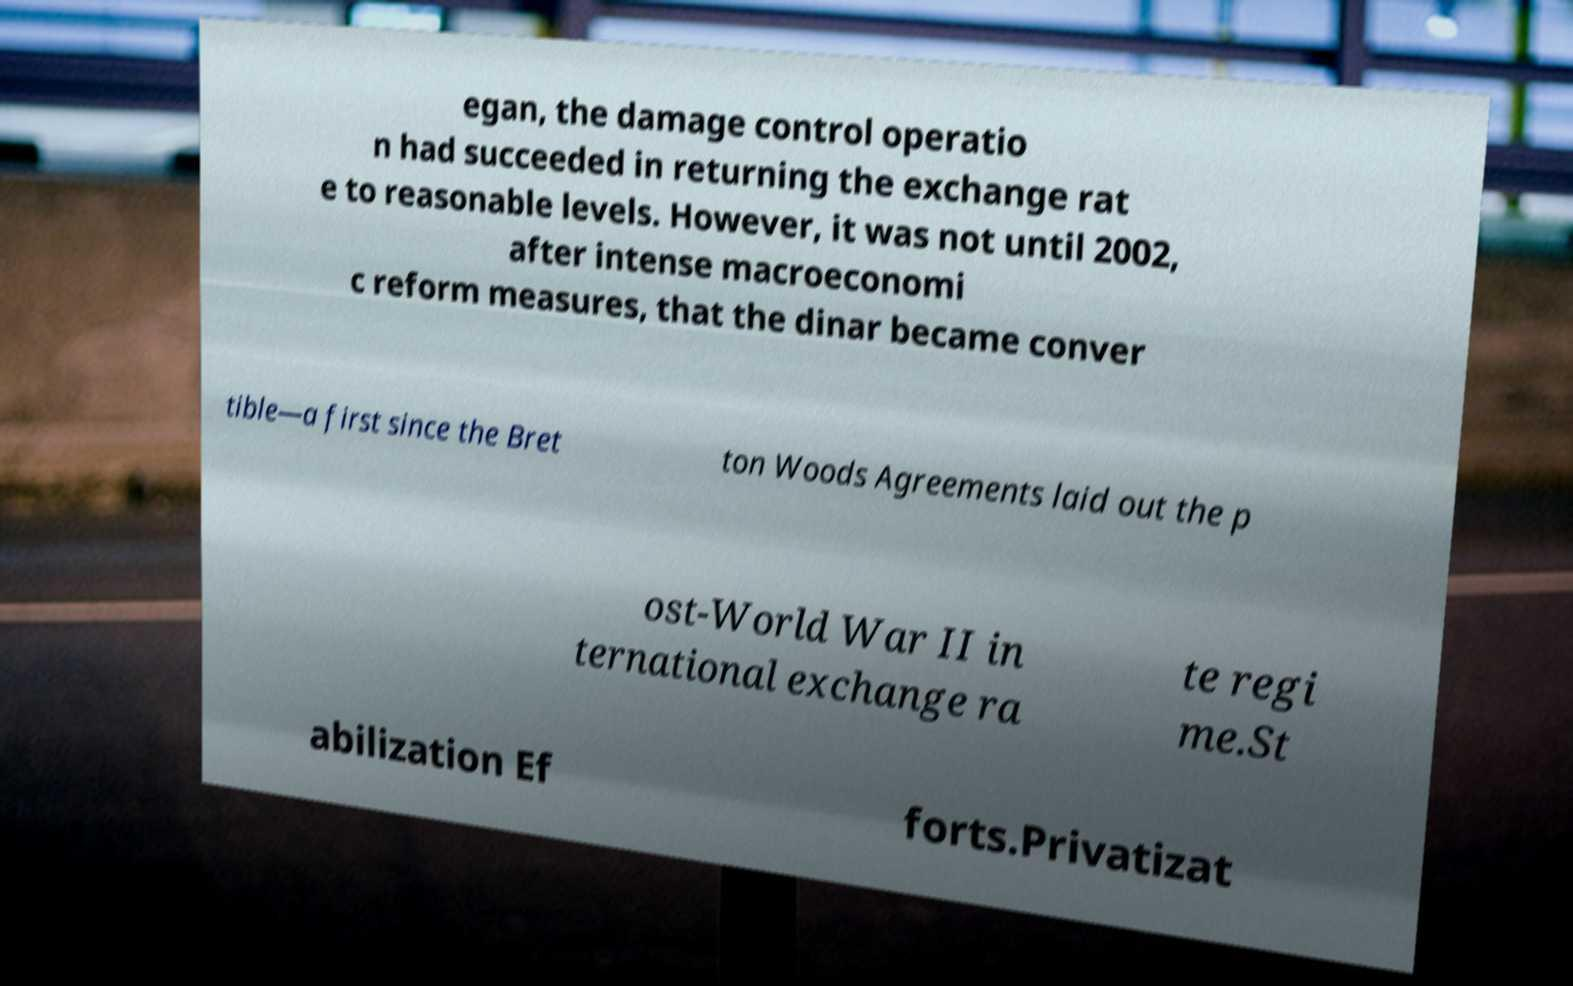Could you extract and type out the text from this image? egan, the damage control operatio n had succeeded in returning the exchange rat e to reasonable levels. However, it was not until 2002, after intense macroeconomi c reform measures, that the dinar became conver tible—a first since the Bret ton Woods Agreements laid out the p ost-World War II in ternational exchange ra te regi me.St abilization Ef forts.Privatizat 